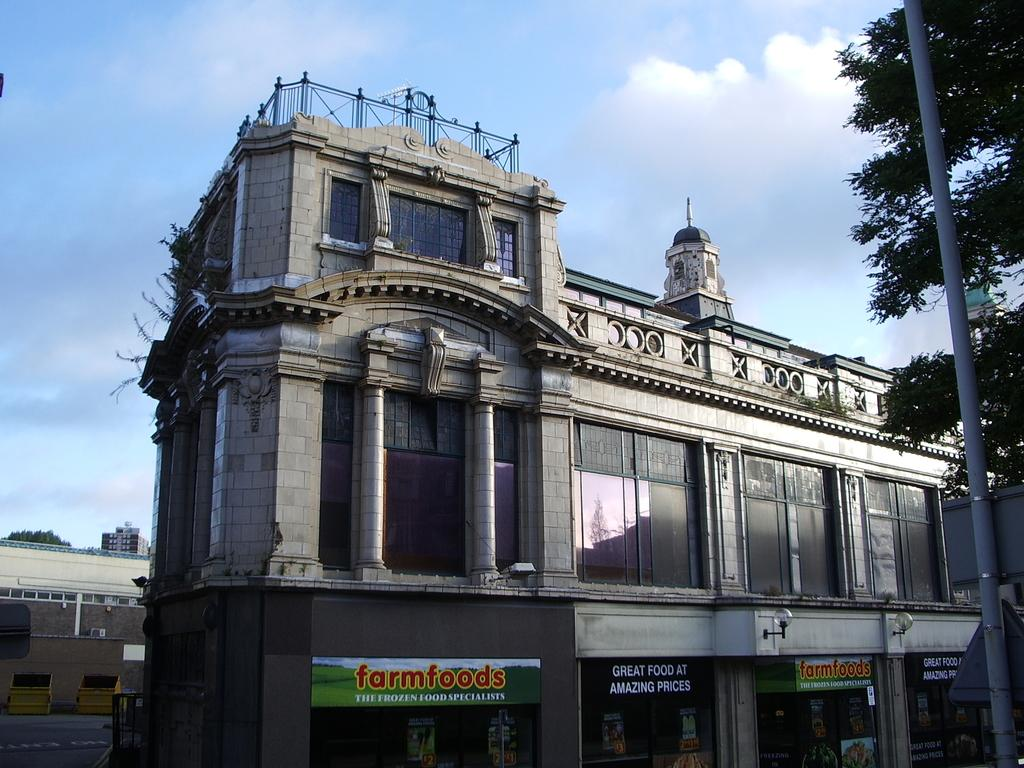Provide a one-sentence caption for the provided image. A beautiful building for Farmfoods that sell frozen food with an amazing price. 